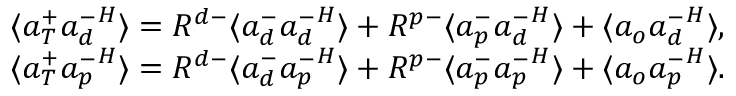Convert formula to latex. <formula><loc_0><loc_0><loc_500><loc_500>\begin{array} { r } { \langle { a } _ { T } ^ { + } { { a } _ { d } ^ { - } } ^ { H } \rangle = R ^ { d - } \langle { a } _ { d } ^ { - } { { a } _ { d } ^ { - } } ^ { H } \rangle + R ^ { p - } \langle { a } _ { p } ^ { - } { { a } _ { d } ^ { - } } ^ { H } \rangle + \langle { a } _ { o } { { a } _ { d } ^ { - } } ^ { H } \rangle , } \\ { \langle { a } _ { T } ^ { + } { { a } _ { p } ^ { - } } ^ { H } \rangle = R ^ { d - } \langle { a } _ { d } ^ { - } { { a } _ { p } ^ { - } } ^ { H } \rangle + R ^ { p - } \langle { a } _ { p } ^ { - } { { a } _ { p } ^ { - } } ^ { H } \rangle + \langle { a } _ { o } { { a } _ { p } ^ { - } } ^ { H } \rangle . } \end{array}</formula> 